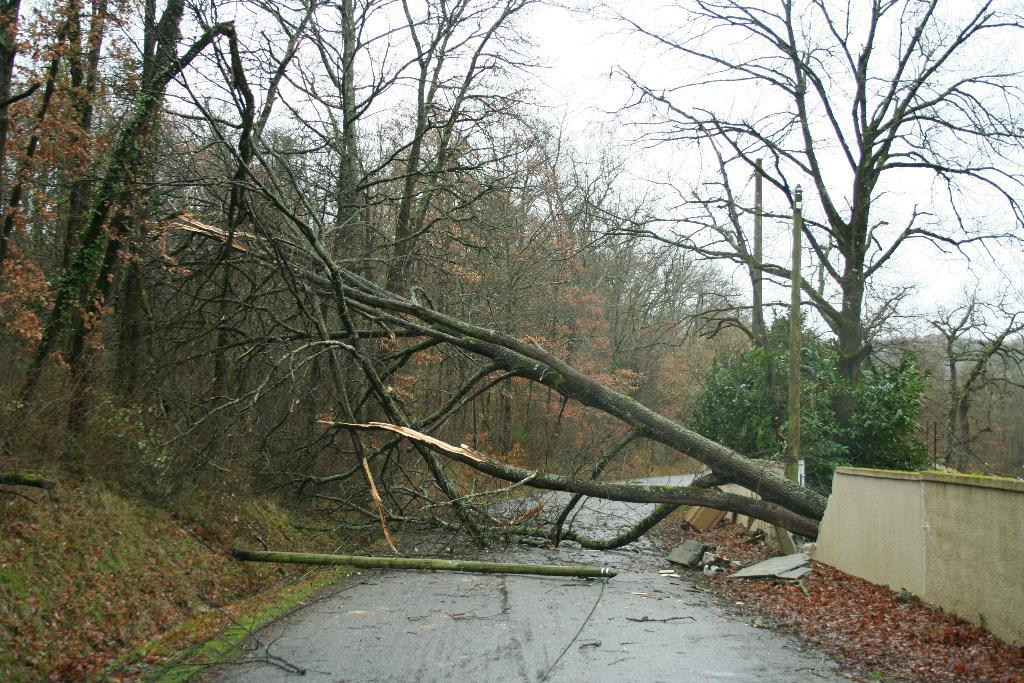What type of pathway is visible in the image? There is a road in the image. What natural elements can be seen in the image? There are trees in the image. What is the condition of the wall in the image? The wall is broken. What vertical structure is present in the image? There is a pole in the image. What part of the trees is damaged in the image? Broken branches of trees are visible in the image. What type of book is the person reading in the image? There is no person reading a book in the image. What type of furniture is present in the image? There is no furniture present in the image. 